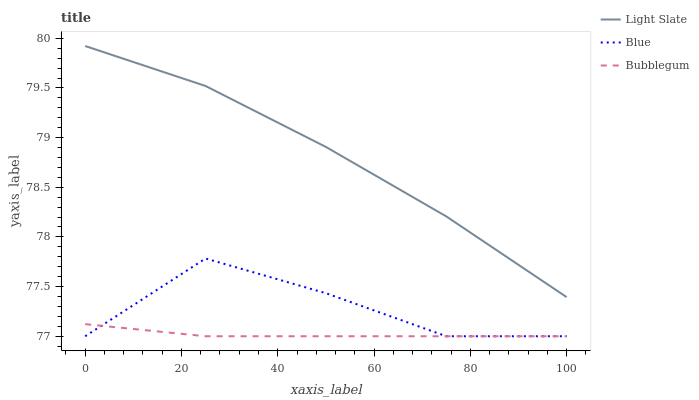Does Blue have the minimum area under the curve?
Answer yes or no. No. Does Blue have the maximum area under the curve?
Answer yes or no. No. Is Blue the smoothest?
Answer yes or no. No. Is Bubblegum the roughest?
Answer yes or no. No. Does Blue have the highest value?
Answer yes or no. No. Is Blue less than Light Slate?
Answer yes or no. Yes. Is Light Slate greater than Bubblegum?
Answer yes or no. Yes. Does Blue intersect Light Slate?
Answer yes or no. No. 